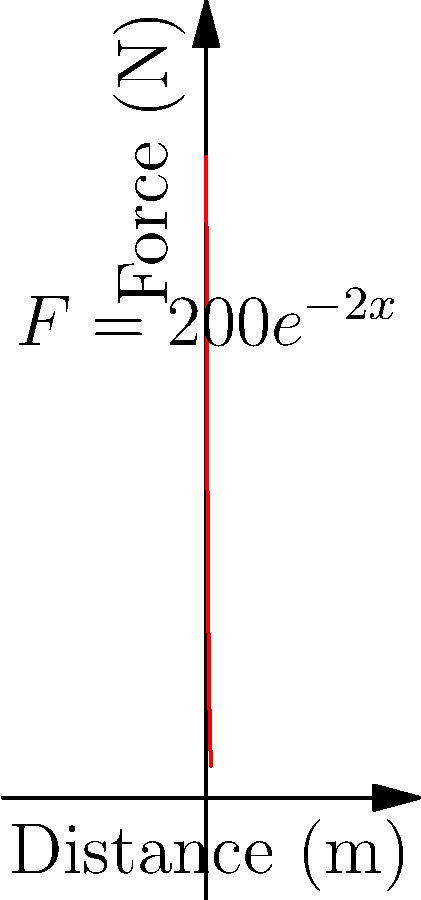As a shot putter, you're analyzing the force-distance curve for a throw. The force $F$ (in Newtons) exerted on the shot as a function of distance $x$ (in meters) is given by $F(x) = 200e^{-2x}$. Calculate the work done in pushing the shot from $x = 0$ to $x = 1$ meter. To find the work done, we need to calculate the area under the force-distance curve from $x = 0$ to $x = 1$. This can be done using integration:

1) The work $W$ is given by the integral:
   $$W = \int_0^1 F(x) dx = \int_0^1 200e^{-2x} dx$$

2) To integrate, we use the rule $\int e^{ax} dx = \frac{1}{a}e^{ax} + C$:
   $$W = 200 \int_0^1 e^{-2x} dx = 200 \cdot \left[-\frac{1}{2}e^{-2x}\right]_0^1$$

3) Evaluate the integral:
   $$W = 200 \cdot \left(-\frac{1}{2}e^{-2} - (-\frac{1}{2}e^0)\right)$$

4) Simplify:
   $$W = 200 \cdot \left(-\frac{1}{2}e^{-2} + \frac{1}{2}\right) = 100 \cdot (1 - e^{-2})$$

5) Calculate the final value:
   $$W \approx 86.47 \text{ J}$$

Thus, the work done in pushing the shot from 0 to 1 meter is approximately 86.47 Joules.
Answer: 86.47 J 